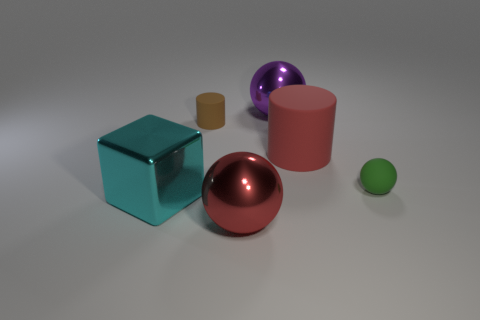There is a red thing that is in front of the big thing that is to the left of the large red sphere that is on the right side of the block; how big is it?
Your answer should be very brief. Large. Is the color of the large sphere that is behind the large cyan metallic object the same as the cube?
Keep it short and to the point. No. There is another object that is the same shape as the red rubber object; what size is it?
Offer a terse response. Small. How many objects are tiny objects that are to the right of the red matte thing or balls in front of the small brown cylinder?
Your response must be concise. 2. The tiny object that is to the left of the metallic object that is behind the tiny brown cylinder is what shape?
Ensure brevity in your answer.  Cylinder. Is there any other thing that is the same color as the rubber ball?
Keep it short and to the point. No. Is there anything else that is the same size as the cyan metal object?
Your answer should be very brief. Yes. How many things are small blue metallic spheres or big red things?
Give a very brief answer. 2. Is there a brown rubber object that has the same size as the brown cylinder?
Ensure brevity in your answer.  No. What shape is the red metal thing?
Give a very brief answer. Sphere. 